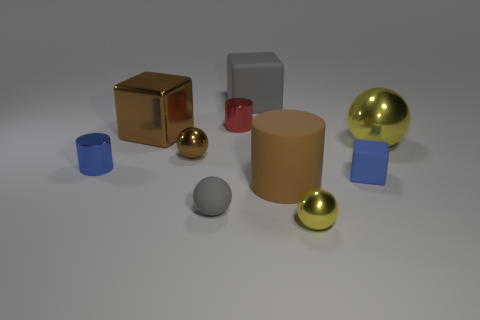Subtract 2 balls. How many balls are left? 2 Subtract all purple balls. Subtract all purple cubes. How many balls are left? 4 Subtract all cylinders. How many objects are left? 7 Add 6 tiny blue cubes. How many tiny blue cubes are left? 7 Add 4 big matte blocks. How many big matte blocks exist? 5 Subtract 0 cyan spheres. How many objects are left? 10 Subtract all small red things. Subtract all red metal cylinders. How many objects are left? 8 